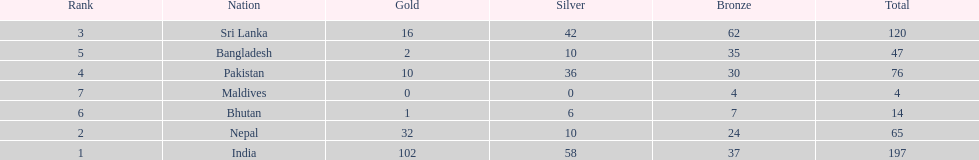Name a country listed in the table, other than india? Nepal. 